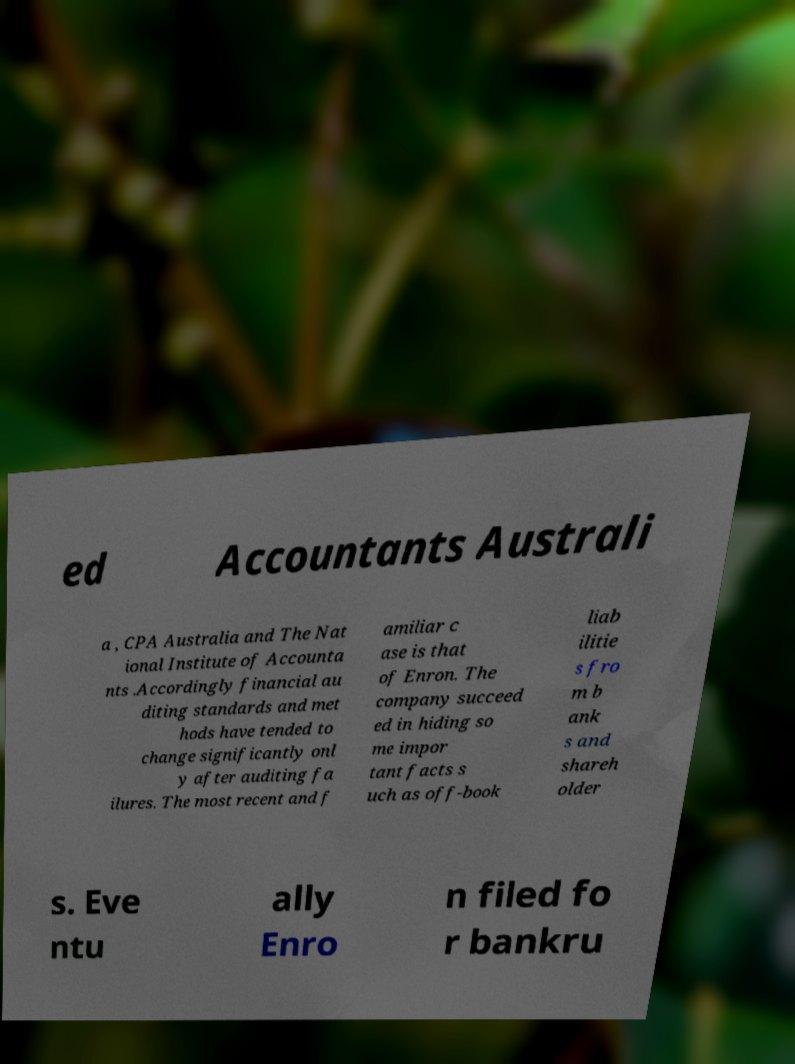There's text embedded in this image that I need extracted. Can you transcribe it verbatim? ed Accountants Australi a , CPA Australia and The Nat ional Institute of Accounta nts .Accordingly financial au diting standards and met hods have tended to change significantly onl y after auditing fa ilures. The most recent and f amiliar c ase is that of Enron. The company succeed ed in hiding so me impor tant facts s uch as off-book liab ilitie s fro m b ank s and shareh older s. Eve ntu ally Enro n filed fo r bankru 